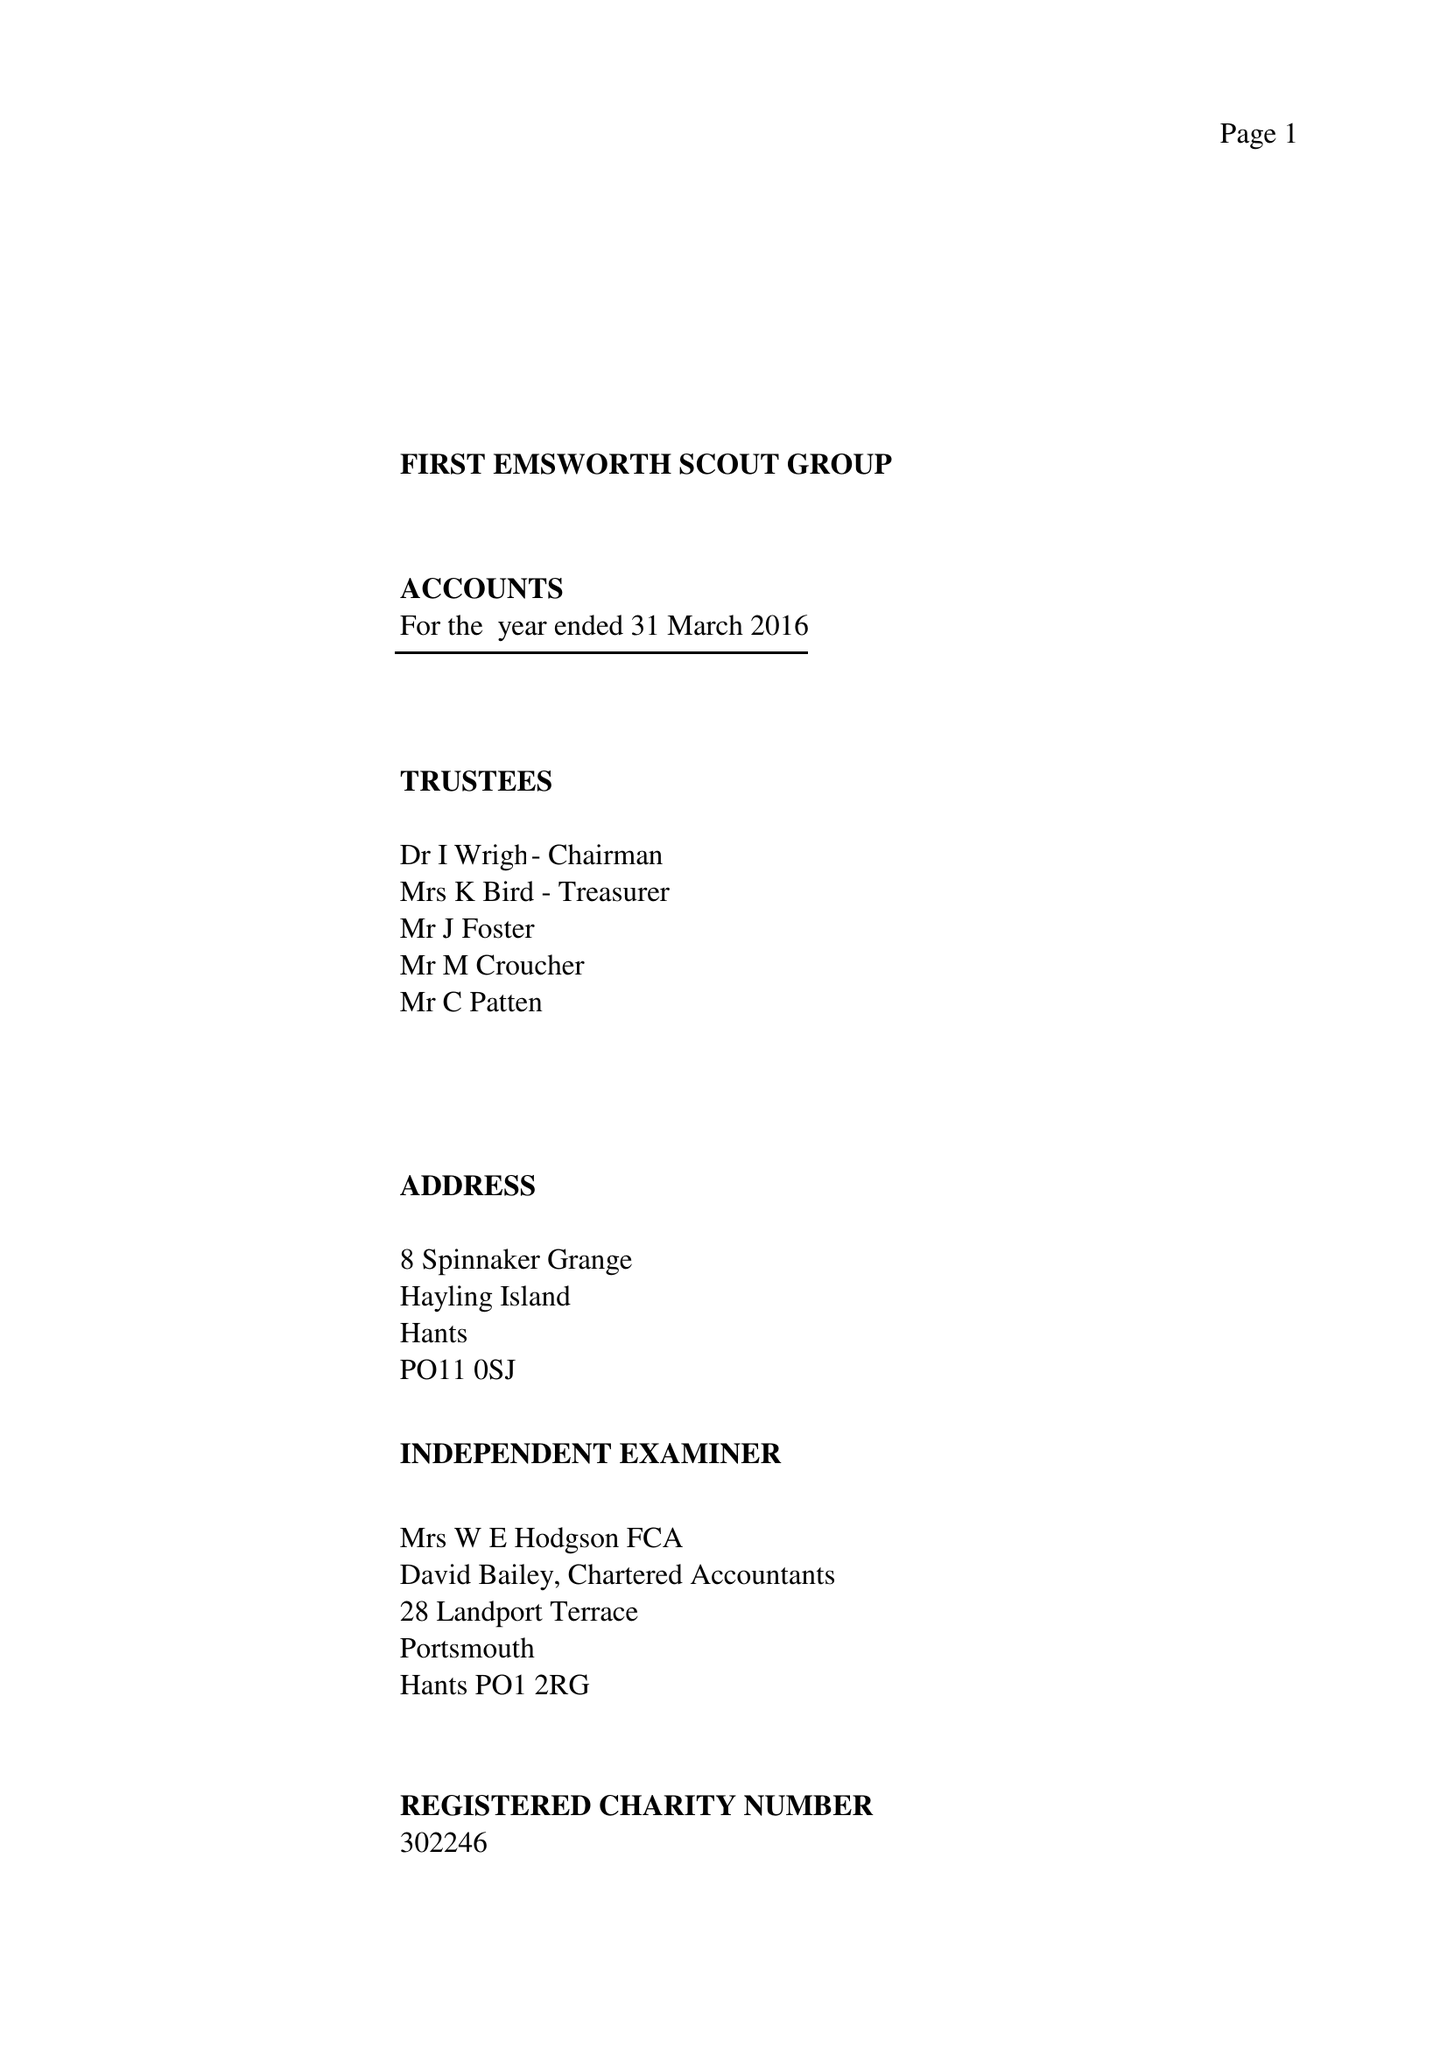What is the value for the address__postcode?
Answer the question using a single word or phrase. PO11 0SJ 